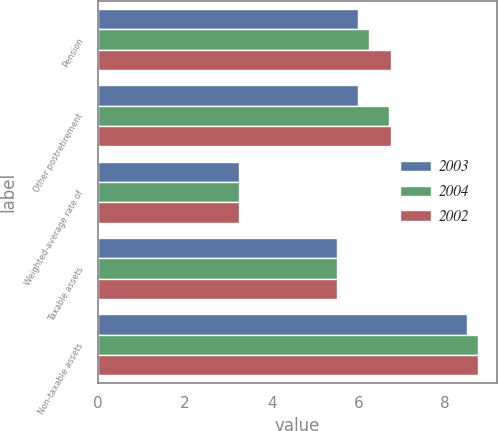Convert chart. <chart><loc_0><loc_0><loc_500><loc_500><stacked_bar_chart><ecel><fcel>Pension<fcel>Other postretirement<fcel>Weighted-average rate of<fcel>Taxable assets<fcel>Non-taxable assets<nl><fcel>2003<fcel>6<fcel>6<fcel>3.25<fcel>5.5<fcel>8.5<nl><fcel>2004<fcel>6.25<fcel>6.71<fcel>3.25<fcel>5.5<fcel>8.75<nl><fcel>2002<fcel>6.75<fcel>6.75<fcel>3.25<fcel>5.5<fcel>8.75<nl></chart> 